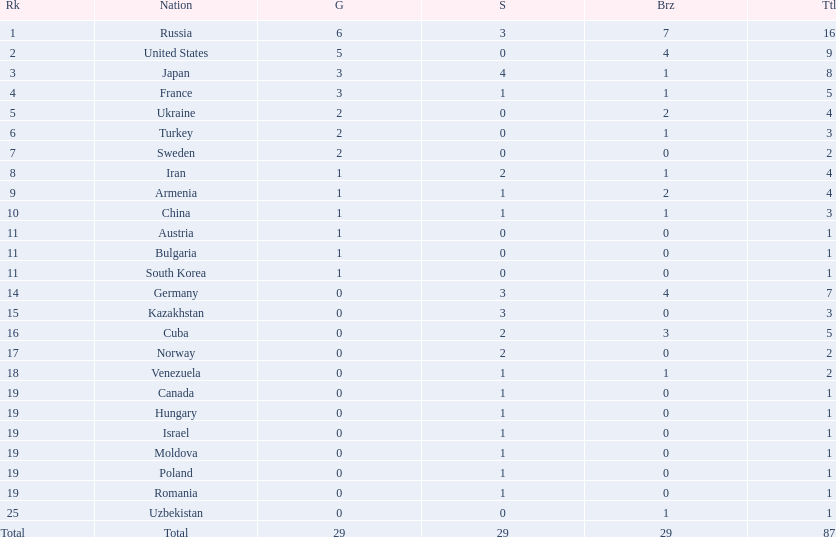Which nations participated in the 1995 world wrestling championships? Russia, United States, Japan, France, Ukraine, Turkey, Sweden, Iran, Armenia, China, Austria, Bulgaria, South Korea, Germany, Kazakhstan, Cuba, Norway, Venezuela, Canada, Hungary, Israel, Moldova, Poland, Romania, Uzbekistan. And between iran and germany, which one placed in the top 10? Germany. 